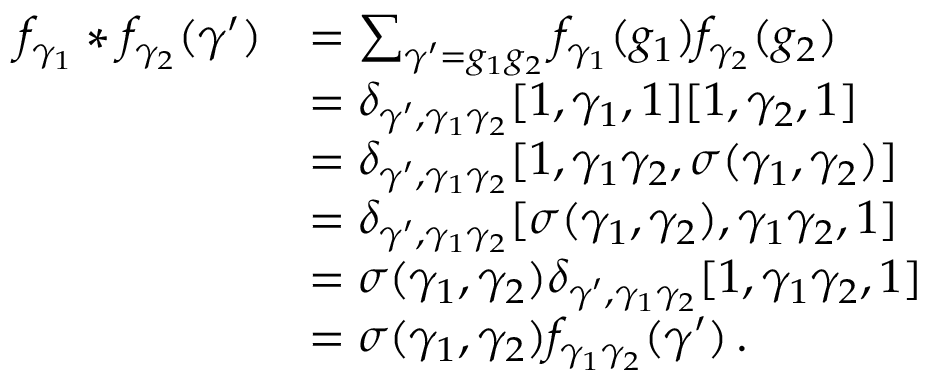<formula> <loc_0><loc_0><loc_500><loc_500>\begin{array} { r l } { f _ { \gamma _ { 1 } } * f _ { \gamma _ { 2 } } ( \gamma ^ { \prime } ) } & { = \sum _ { \gamma ^ { \prime } = g _ { 1 } g _ { 2 } } f _ { \gamma _ { 1 } } ( g _ { 1 } ) f _ { \gamma _ { 2 } } ( g _ { 2 } ) } \\ & { = \delta _ { \gamma ^ { \prime } , \gamma _ { 1 } \gamma _ { 2 } } [ 1 , \gamma _ { 1 } , 1 ] [ 1 , \gamma _ { 2 } , 1 ] } \\ & { = \delta _ { \gamma ^ { \prime } , \gamma _ { 1 } \gamma _ { 2 } } [ 1 , \gamma _ { 1 } \gamma _ { 2 } , \sigma ( \gamma _ { 1 } , \gamma _ { 2 } ) ] } \\ & { = \delta _ { \gamma ^ { \prime } , \gamma _ { 1 } \gamma _ { 2 } } [ \sigma ( \gamma _ { 1 } , \gamma _ { 2 } ) , \gamma _ { 1 } \gamma _ { 2 } , 1 ] } \\ & { = \sigma ( \gamma _ { 1 } , \gamma _ { 2 } ) \delta _ { \gamma ^ { \prime } , \gamma _ { 1 } \gamma _ { 2 } } [ 1 , \gamma _ { 1 } \gamma _ { 2 } , 1 ] } \\ & { = \sigma ( \gamma _ { 1 } , \gamma _ { 2 } ) f _ { \gamma _ { 1 } \gamma _ { 2 } } ( \gamma ^ { \prime } ) { \, . } } \end{array}</formula> 